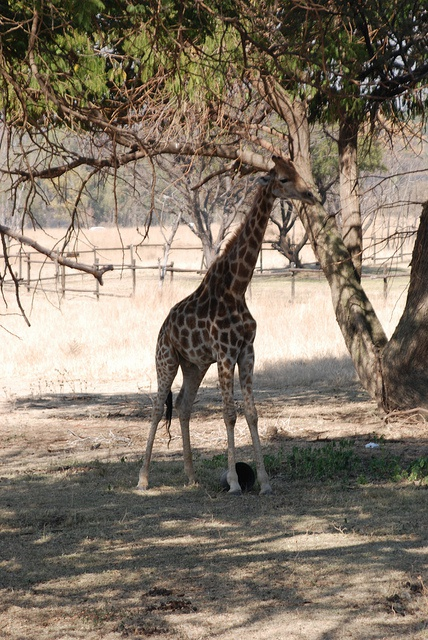Describe the objects in this image and their specific colors. I can see a giraffe in black and gray tones in this image. 